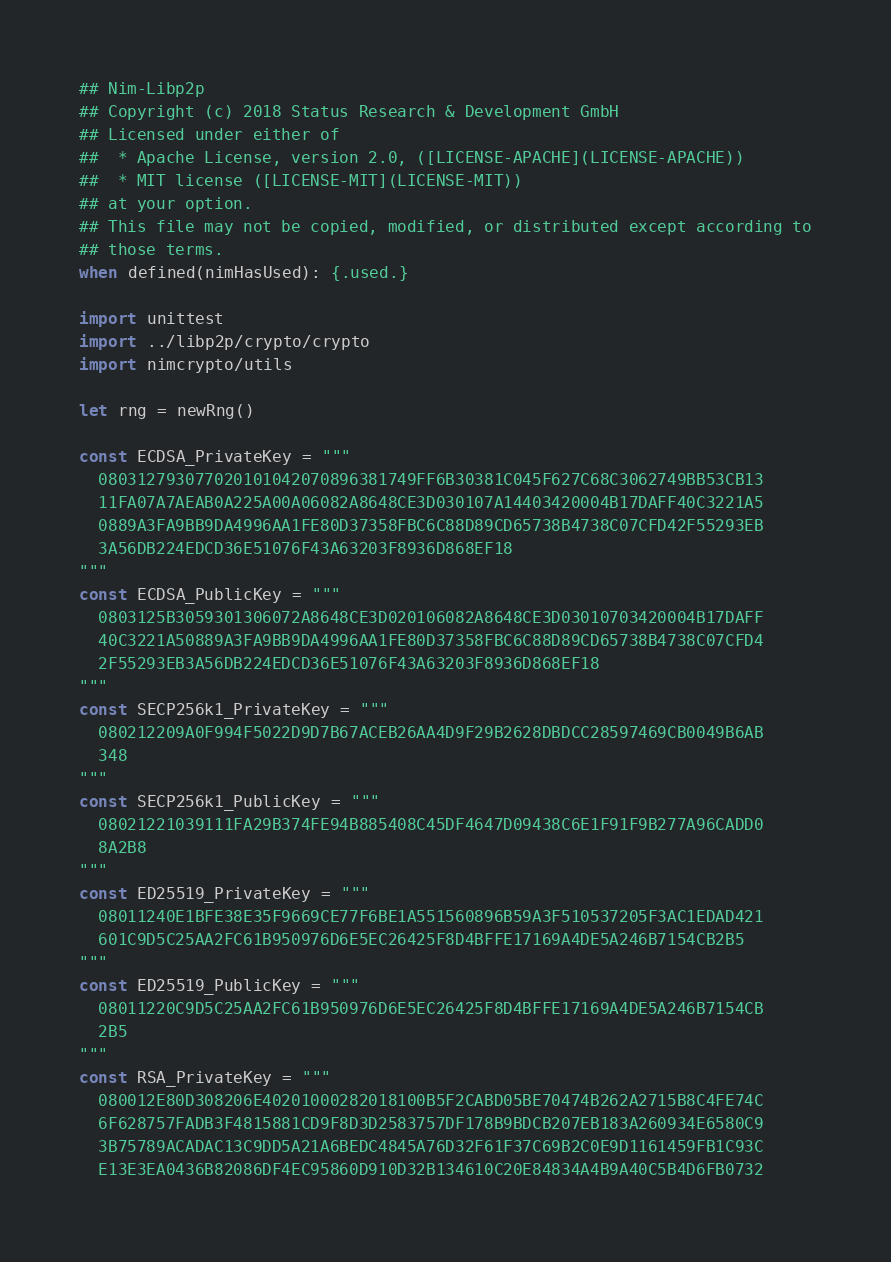Convert code to text. <code><loc_0><loc_0><loc_500><loc_500><_Nim_>## Nim-Libp2p
## Copyright (c) 2018 Status Research & Development GmbH
## Licensed under either of
##  * Apache License, version 2.0, ([LICENSE-APACHE](LICENSE-APACHE))
##  * MIT license ([LICENSE-MIT](LICENSE-MIT))
## at your option.
## This file may not be copied, modified, or distributed except according to
## those terms.
when defined(nimHasUsed): {.used.}

import unittest
import ../libp2p/crypto/crypto
import nimcrypto/utils

let rng = newRng()

const ECDSA_PrivateKey = """
  080312793077020101042070896381749FF6B30381C045F627C68C3062749BB53CB13
  11FA07A7AEAB0A225A00A06082A8648CE3D030107A14403420004B17DAFF40C3221A5
  0889A3FA9BB9DA4996AA1FE80D37358FBC6C88D89CD65738B4738C07CFD42F55293EB
  3A56DB224EDCD36E51076F43A63203F8936D868EF18
"""
const ECDSA_PublicKey = """
  0803125B3059301306072A8648CE3D020106082A8648CE3D03010703420004B17DAFF
  40C3221A50889A3FA9BB9DA4996AA1FE80D37358FBC6C88D89CD65738B4738C07CFD4
  2F55293EB3A56DB224EDCD36E51076F43A63203F8936D868EF18
"""
const SECP256k1_PrivateKey = """
  080212209A0F994F5022D9D7B67ACEB26AA4D9F29B2628DBDCC28597469CB0049B6AB
  348
"""
const SECP256k1_PublicKey = """
  08021221039111FA29B374FE94B885408C45DF4647D09438C6E1F91F9B277A96CADD0
  8A2B8
"""
const ED25519_PrivateKey = """
  08011240E1BFE38E35F9669CE77F6BE1A551560896B59A3F510537205F3AC1EDAD421
  601C9D5C25AA2FC61B950976D6E5EC26425F8D4BFFE17169A4DE5A246B7154CB2B5
"""
const ED25519_PublicKey = """
  08011220C9D5C25AA2FC61B950976D6E5EC26425F8D4BFFE17169A4DE5A246B7154CB
  2B5
"""
const RSA_PrivateKey = """
  080012E80D308206E40201000282018100B5F2CABD05BE70474B262A2715B8C4FE74C
  6F628757FADB3F4815881CD9F8D3D2583757DF178B9BDCB207EB183A260934E6580C9
  3B75789ACADAC13C9DD5A21A6BEDC4845A76D32F61F37C69B2C0E9D1161459FB1C93C
  E13E3EA0436B82086DF4EC95860D910D32B134610C20E84834A4B9A40C5B4D6FB0732</code> 